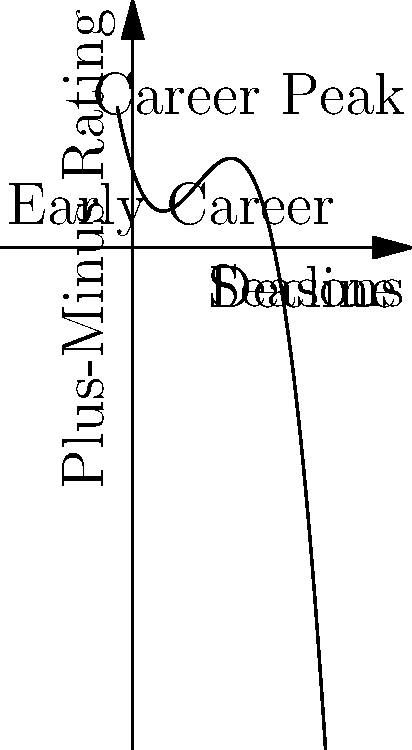The graph represents Patrick Marleau's plus-minus rating throughout his NHL career. Based on the polynomial function depicted, at approximately which season did Marleau's plus-minus rating reach its peak? To find the season when Patrick Marleau's plus-minus rating reached its peak, we need to analyze the graph:

1. The x-axis represents the seasons in Marleau's career.
2. The y-axis represents his plus-minus rating.
3. The curve shows a polynomial function that models his performance over time.
4. The peak of the curve represents the highest plus-minus rating in his career.
5. By examining the graph, we can see that the curve reaches its maximum point around the 15th season mark on the x-axis.
6. This point is also labeled "Career Peak" on the graph, confirming our observation.

Therefore, according to this polynomial model, Patrick Marleau's plus-minus rating reached its peak around his 15th NHL season.
Answer: 15th season 